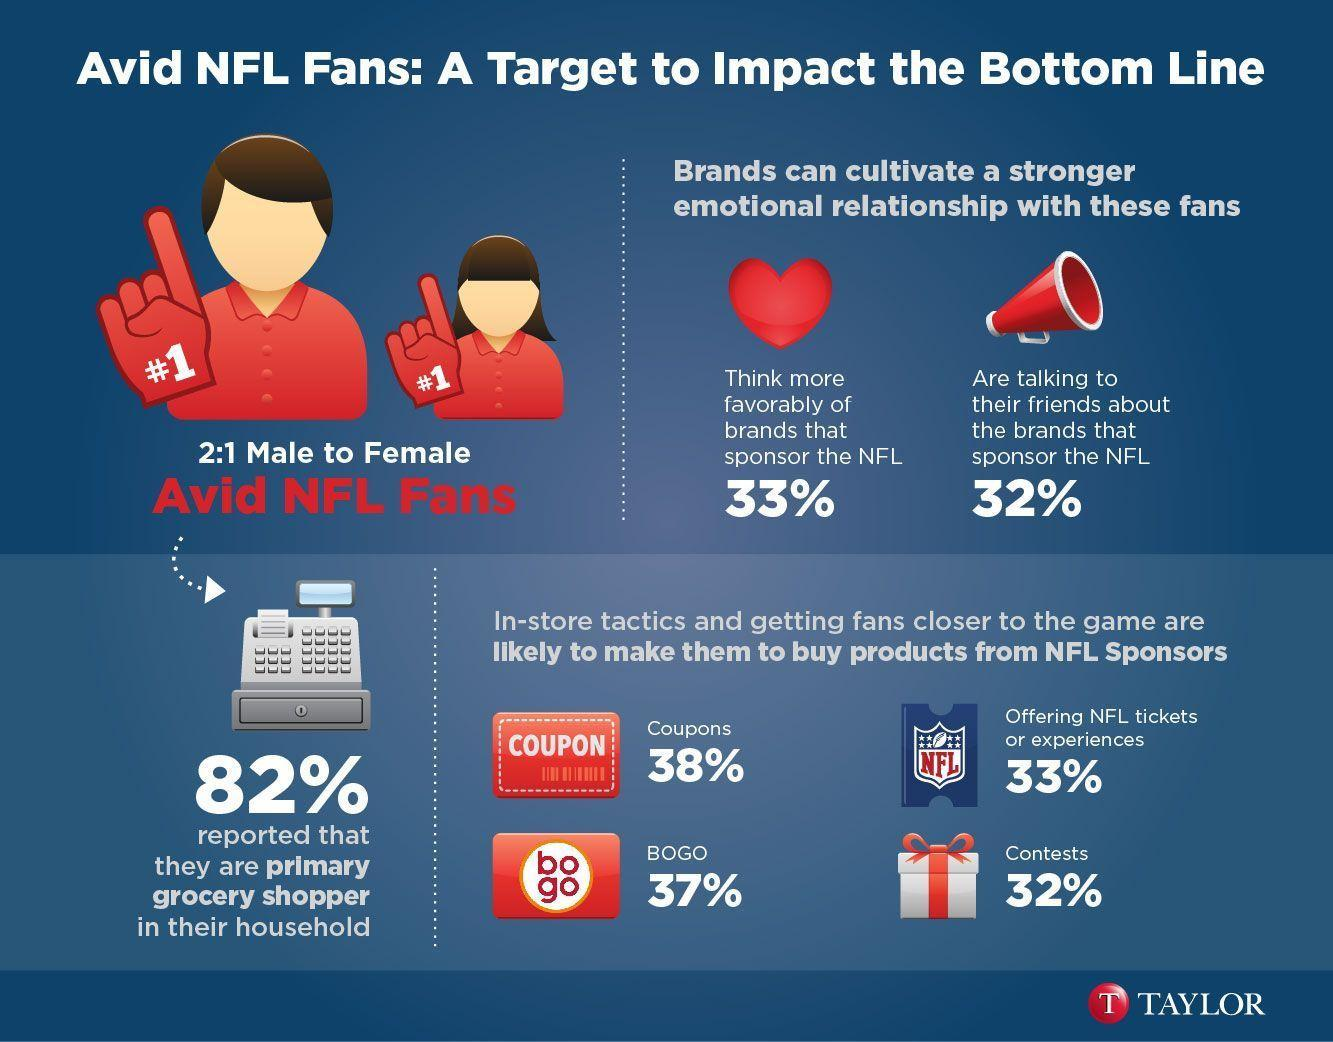What percentage of stores use NFL coupons to attract consumers, 82%, 38%, or 33%?
Answer the question with a short phrase. 38% Which in-store tactics is used by 32% of stores to make consumers buy products? Contests 